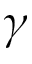<formula> <loc_0><loc_0><loc_500><loc_500>\gamma</formula> 